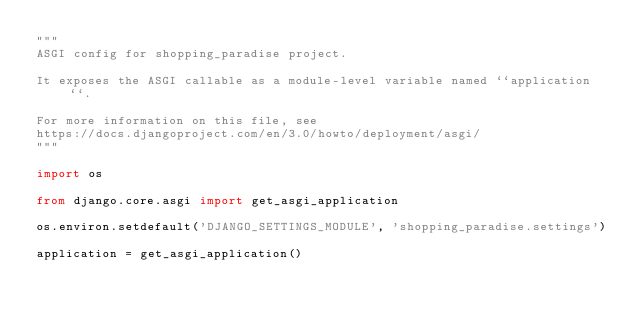<code> <loc_0><loc_0><loc_500><loc_500><_Python_>"""
ASGI config for shopping_paradise project.

It exposes the ASGI callable as a module-level variable named ``application``.

For more information on this file, see
https://docs.djangoproject.com/en/3.0/howto/deployment/asgi/
"""

import os

from django.core.asgi import get_asgi_application

os.environ.setdefault('DJANGO_SETTINGS_MODULE', 'shopping_paradise.settings')

application = get_asgi_application()
</code> 